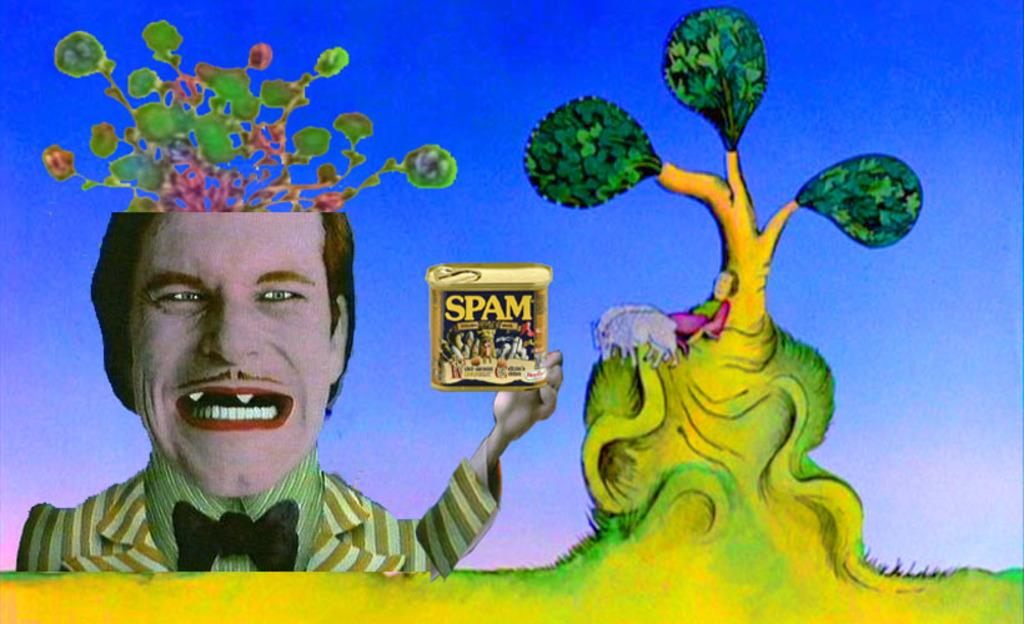What is the main subject of the image? There is an animated person in the image. What is the animated person holding? The person is holding a container. Can you describe the background of the image? There is a woman, two animals, and a tree in the background of the image. What type of hat is the sponge wearing in the image? There is no sponge or hat present in the image. What scene is depicted in the image? The image does not depict a specific scene; it features an animated person holding a container and a background with a woman, two animals, and a tree. 